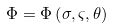<formula> <loc_0><loc_0><loc_500><loc_500>\Phi = \Phi \left ( \sigma , \varsigma , \theta \right )</formula> 